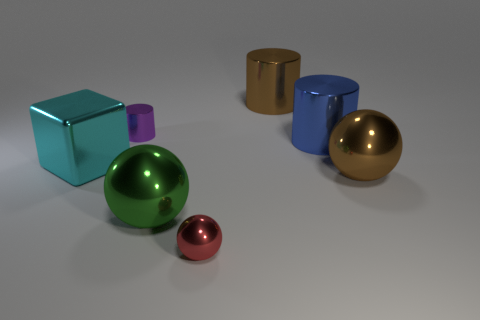Add 1 small shiny spheres. How many objects exist? 8 Add 4 red objects. How many red objects are left? 5 Add 6 large red objects. How many large red objects exist? 6 Subtract all brown cylinders. How many cylinders are left? 2 Subtract all large balls. How many balls are left? 1 Subtract 0 gray balls. How many objects are left? 7 Subtract all blocks. How many objects are left? 6 Subtract 1 cubes. How many cubes are left? 0 Subtract all brown cylinders. Subtract all cyan spheres. How many cylinders are left? 2 Subtract all blue cylinders. How many green blocks are left? 0 